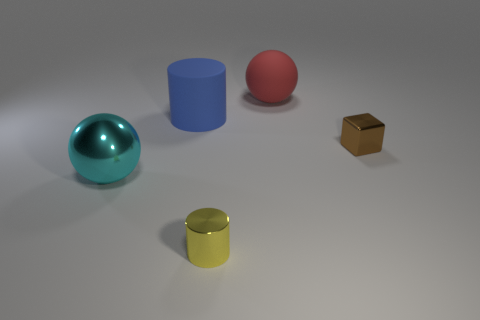What material is the cyan ball?
Offer a terse response. Metal. There is a thing to the left of the large cylinder in front of the big sphere that is behind the large blue thing; what is its color?
Offer a terse response. Cyan. What material is the other big object that is the same shape as the large red matte object?
Your answer should be very brief. Metal. How many rubber balls are the same size as the yellow metal thing?
Your response must be concise. 0. What number of green metal blocks are there?
Ensure brevity in your answer.  0. Is the material of the red object the same as the small object that is in front of the cyan ball?
Offer a terse response. No. What number of cyan things are metal balls or small metallic objects?
Give a very brief answer. 1. There is a sphere that is the same material as the tiny brown object; what size is it?
Offer a terse response. Large. What number of other big matte things have the same shape as the cyan object?
Your response must be concise. 1. Are there more small shiny things that are behind the metallic cylinder than large cyan shiny spheres behind the blue matte cylinder?
Offer a terse response. Yes. 